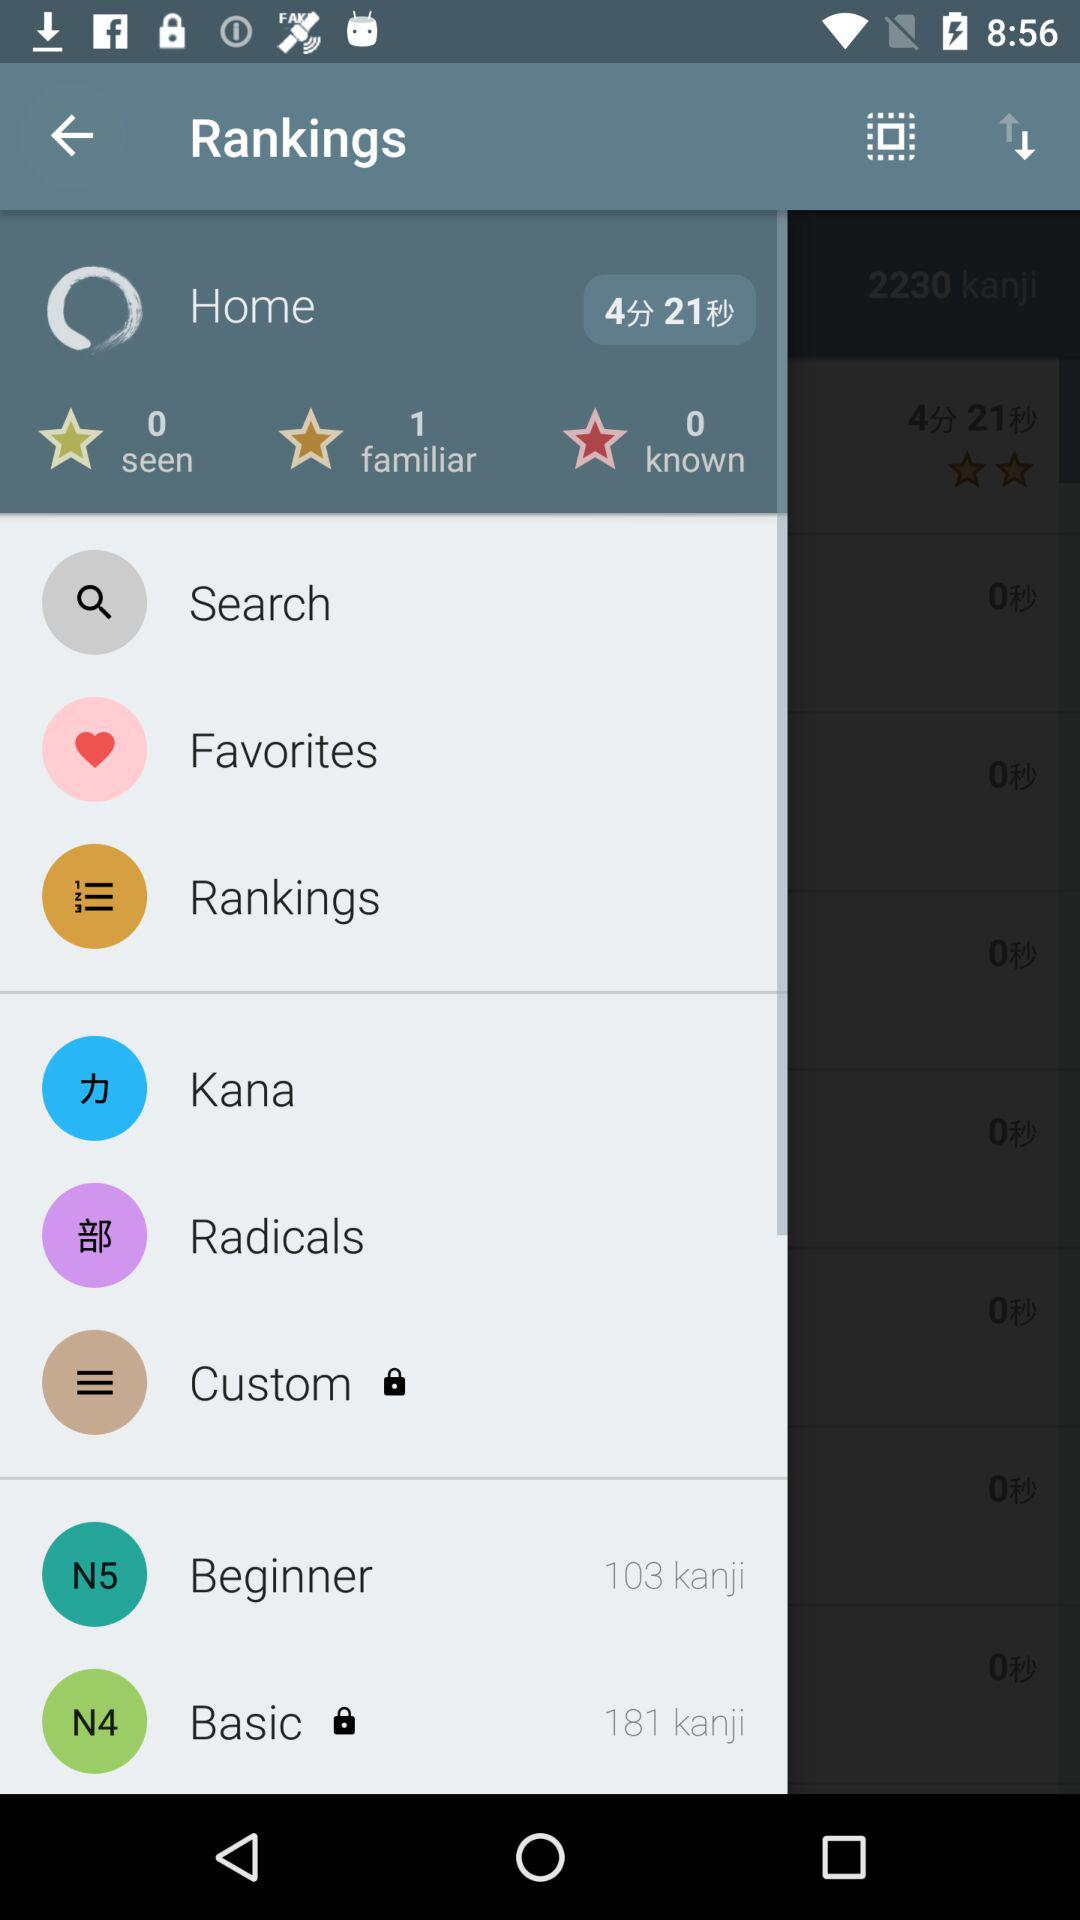What is the total number known? The total number of known is zero. 